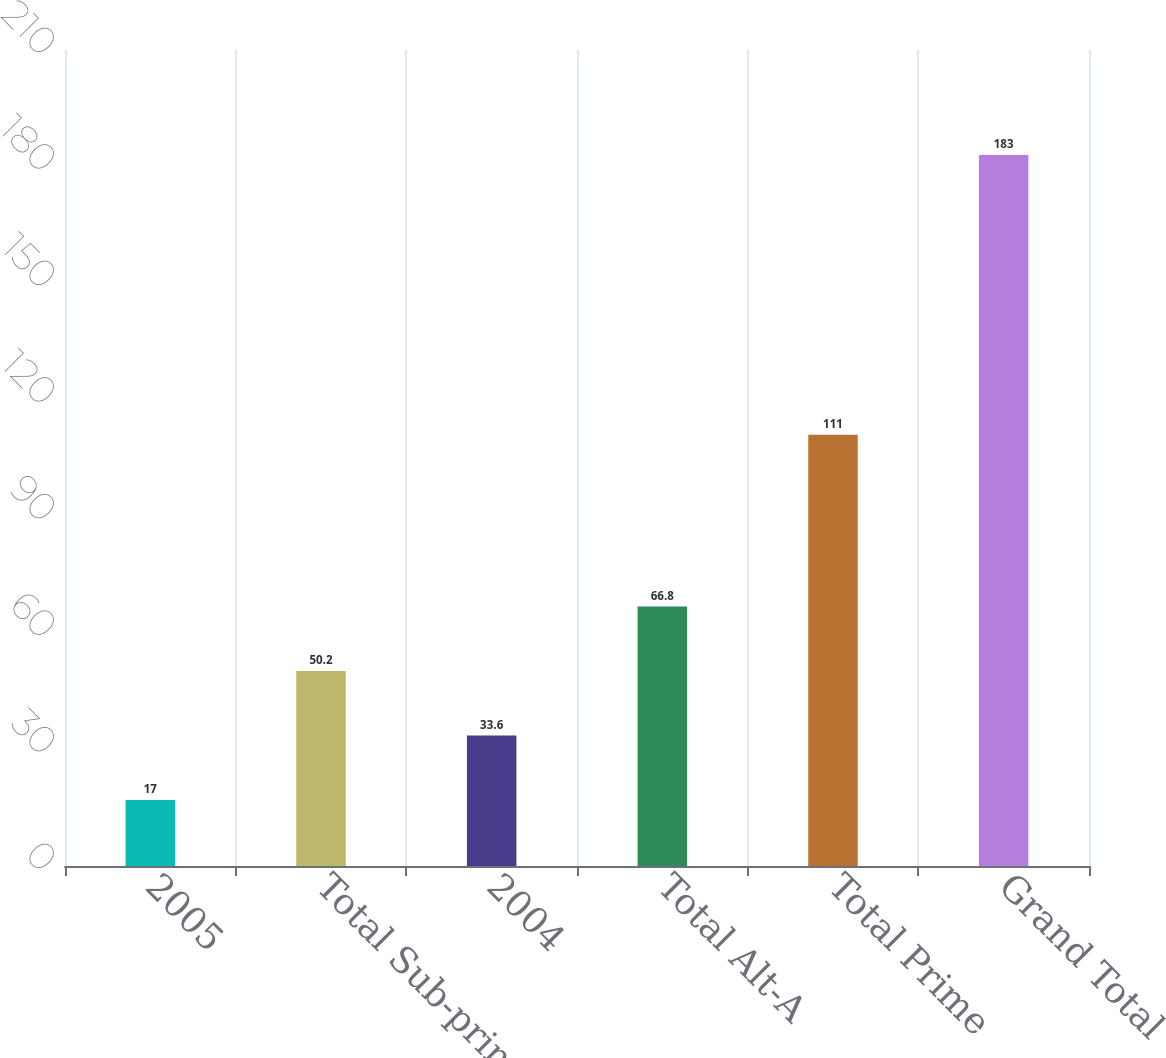<chart> <loc_0><loc_0><loc_500><loc_500><bar_chart><fcel>2005<fcel>Total Sub-prime<fcel>2004<fcel>Total Alt-A<fcel>Total Prime<fcel>Grand Total<nl><fcel>17<fcel>50.2<fcel>33.6<fcel>66.8<fcel>111<fcel>183<nl></chart> 